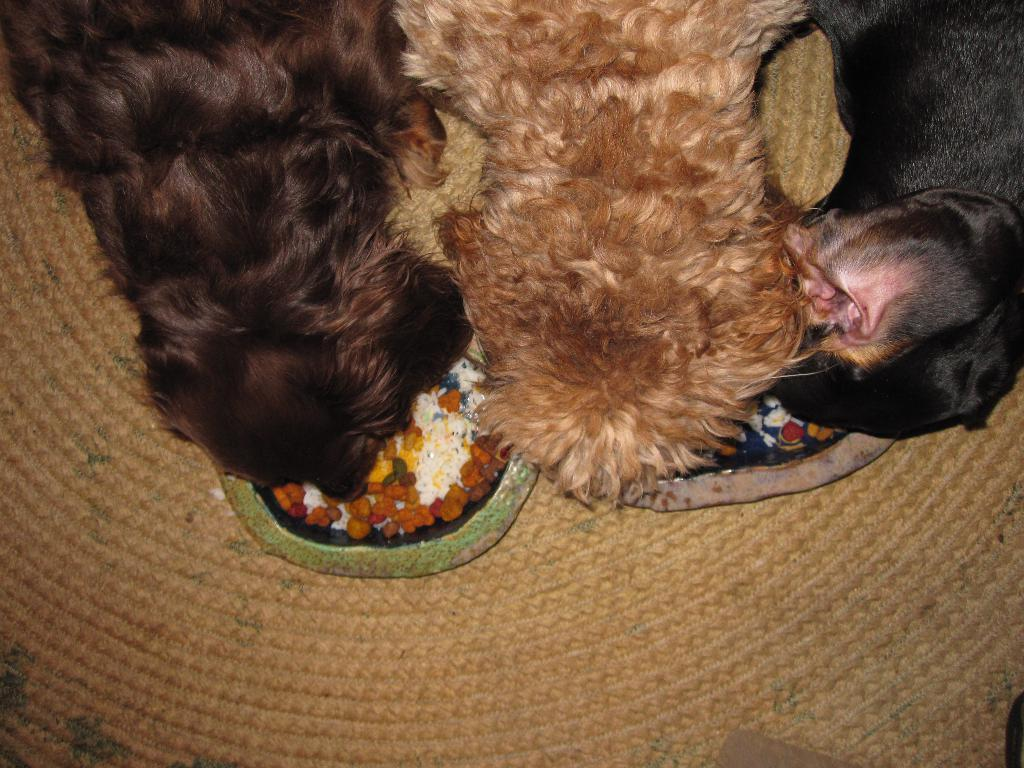How many dogs are visible in the image? There are three dogs in the image. What are the dogs doing in the image? The dogs are having food in the image. How is the food being served to the dogs? The food is placed in bowls in the image. Where are the bowls located? The bowls are present on a mat in the image. What type of shelf can be seen holding the dogs' food in the image? There is no shelf present in the image; the food is placed in bowls on a mat. 